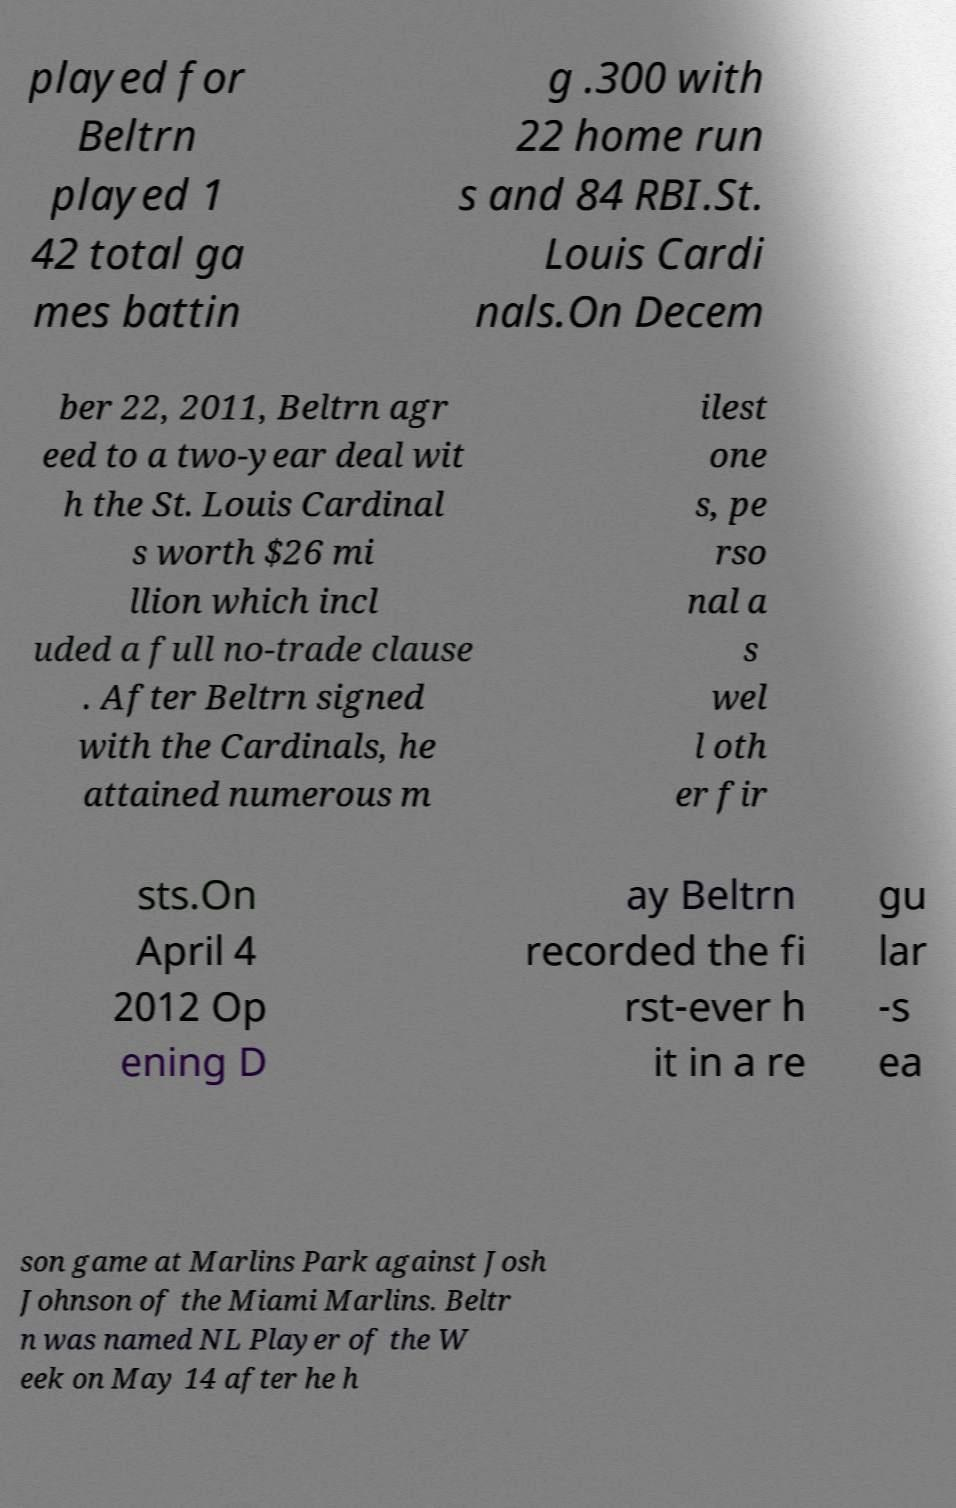There's text embedded in this image that I need extracted. Can you transcribe it verbatim? played for Beltrn played 1 42 total ga mes battin g .300 with 22 home run s and 84 RBI.St. Louis Cardi nals.On Decem ber 22, 2011, Beltrn agr eed to a two-year deal wit h the St. Louis Cardinal s worth $26 mi llion which incl uded a full no-trade clause . After Beltrn signed with the Cardinals, he attained numerous m ilest one s, pe rso nal a s wel l oth er fir sts.On April 4 2012 Op ening D ay Beltrn recorded the fi rst-ever h it in a re gu lar -s ea son game at Marlins Park against Josh Johnson of the Miami Marlins. Beltr n was named NL Player of the W eek on May 14 after he h 